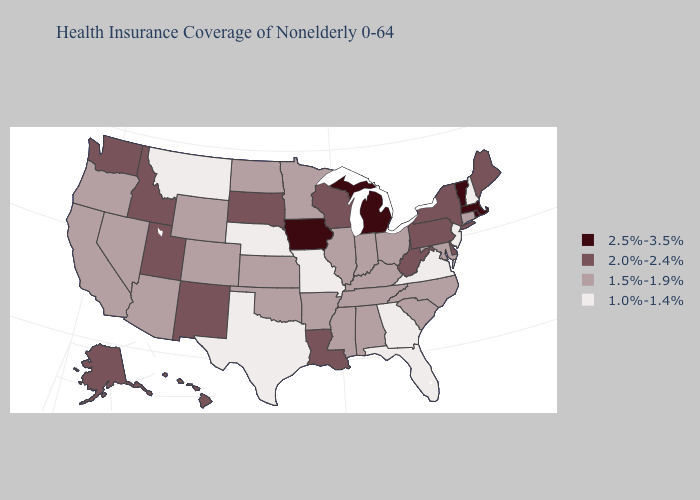Which states have the lowest value in the MidWest?
Keep it brief. Missouri, Nebraska. Name the states that have a value in the range 1.5%-1.9%?
Concise answer only. Alabama, Arizona, Arkansas, California, Colorado, Connecticut, Illinois, Indiana, Kansas, Kentucky, Maryland, Minnesota, Mississippi, Nevada, North Carolina, North Dakota, Ohio, Oklahoma, Oregon, South Carolina, Tennessee, Wyoming. Which states have the lowest value in the USA?
Concise answer only. Florida, Georgia, Missouri, Montana, Nebraska, New Hampshire, New Jersey, Texas, Virginia. What is the highest value in states that border Louisiana?
Be succinct. 1.5%-1.9%. Which states have the lowest value in the MidWest?
Quick response, please. Missouri, Nebraska. What is the highest value in states that border Illinois?
Write a very short answer. 2.5%-3.5%. What is the value of Idaho?
Be succinct. 2.0%-2.4%. Does the first symbol in the legend represent the smallest category?
Write a very short answer. No. What is the value of Oregon?
Write a very short answer. 1.5%-1.9%. Among the states that border Kansas , does Missouri have the lowest value?
Be succinct. Yes. Among the states that border Ohio , does Michigan have the highest value?
Quick response, please. Yes. What is the value of Utah?
Concise answer only. 2.0%-2.4%. What is the value of Rhode Island?
Quick response, please. 2.5%-3.5%. Does Wyoming have the same value as Idaho?
Short answer required. No. What is the value of Maine?
Short answer required. 2.0%-2.4%. 